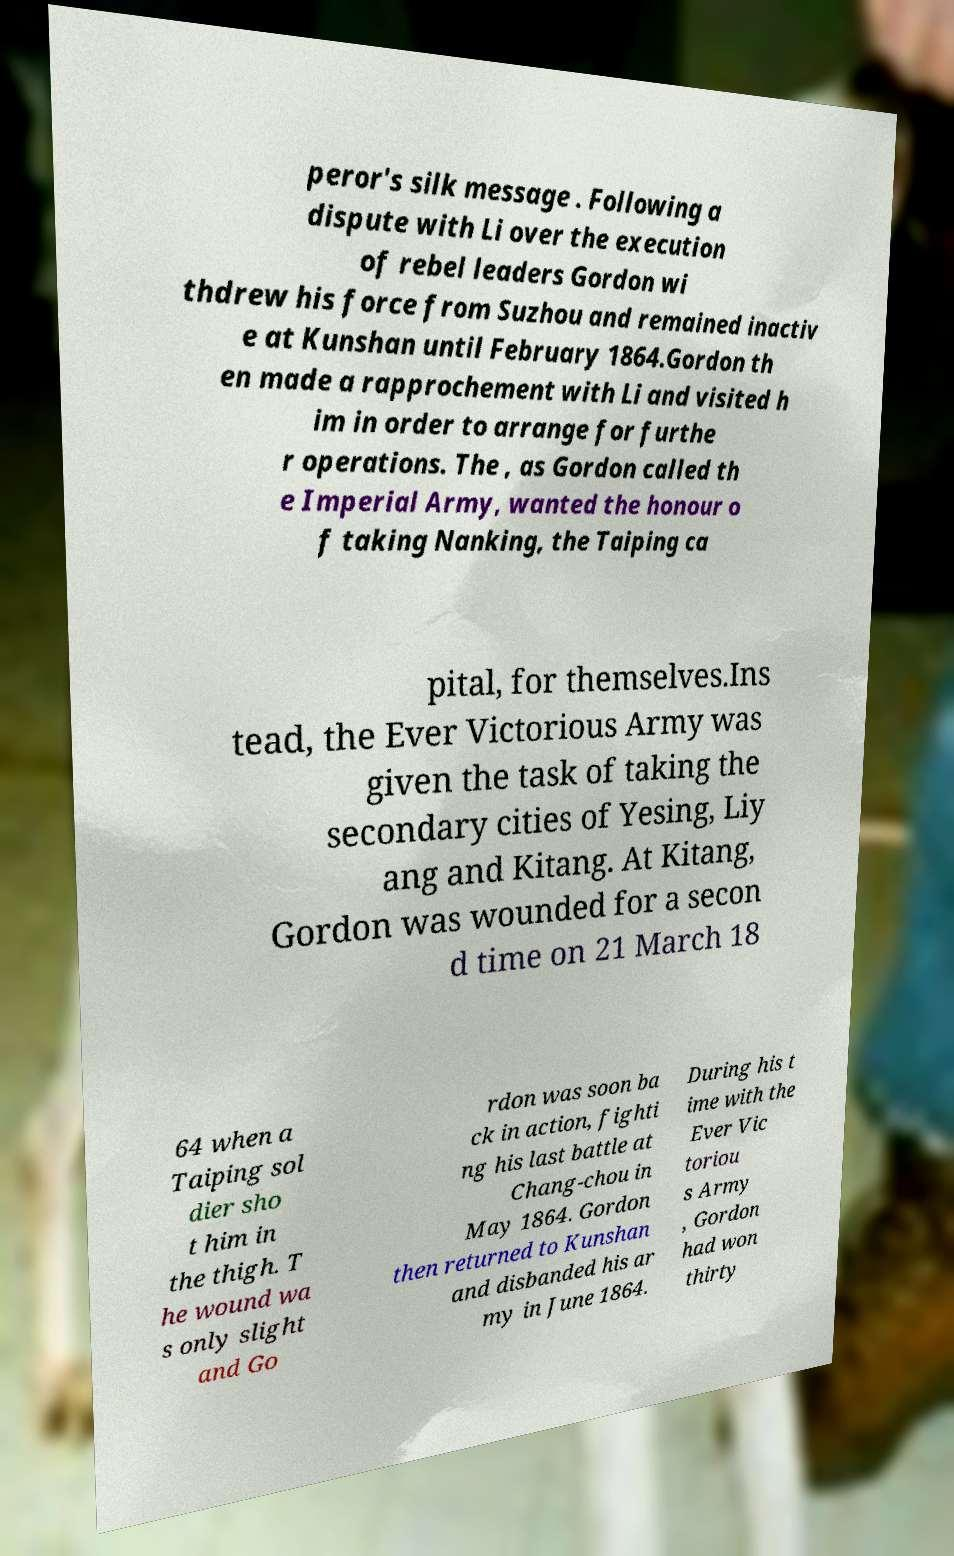Please identify and transcribe the text found in this image. peror's silk message . Following a dispute with Li over the execution of rebel leaders Gordon wi thdrew his force from Suzhou and remained inactiv e at Kunshan until February 1864.Gordon th en made a rapprochement with Li and visited h im in order to arrange for furthe r operations. The , as Gordon called th e Imperial Army, wanted the honour o f taking Nanking, the Taiping ca pital, for themselves.Ins tead, the Ever Victorious Army was given the task of taking the secondary cities of Yesing, Liy ang and Kitang. At Kitang, Gordon was wounded for a secon d time on 21 March 18 64 when a Taiping sol dier sho t him in the thigh. T he wound wa s only slight and Go rdon was soon ba ck in action, fighti ng his last battle at Chang-chou in May 1864. Gordon then returned to Kunshan and disbanded his ar my in June 1864. During his t ime with the Ever Vic toriou s Army , Gordon had won thirty 